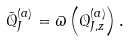Convert formula to latex. <formula><loc_0><loc_0><loc_500><loc_500>\bar { \mathcal { Q } } ^ { ( a ) } _ { J } = \varpi \left ( \mathcal { Q } ^ { ( a ) } _ { J , z } \right ) .</formula> 